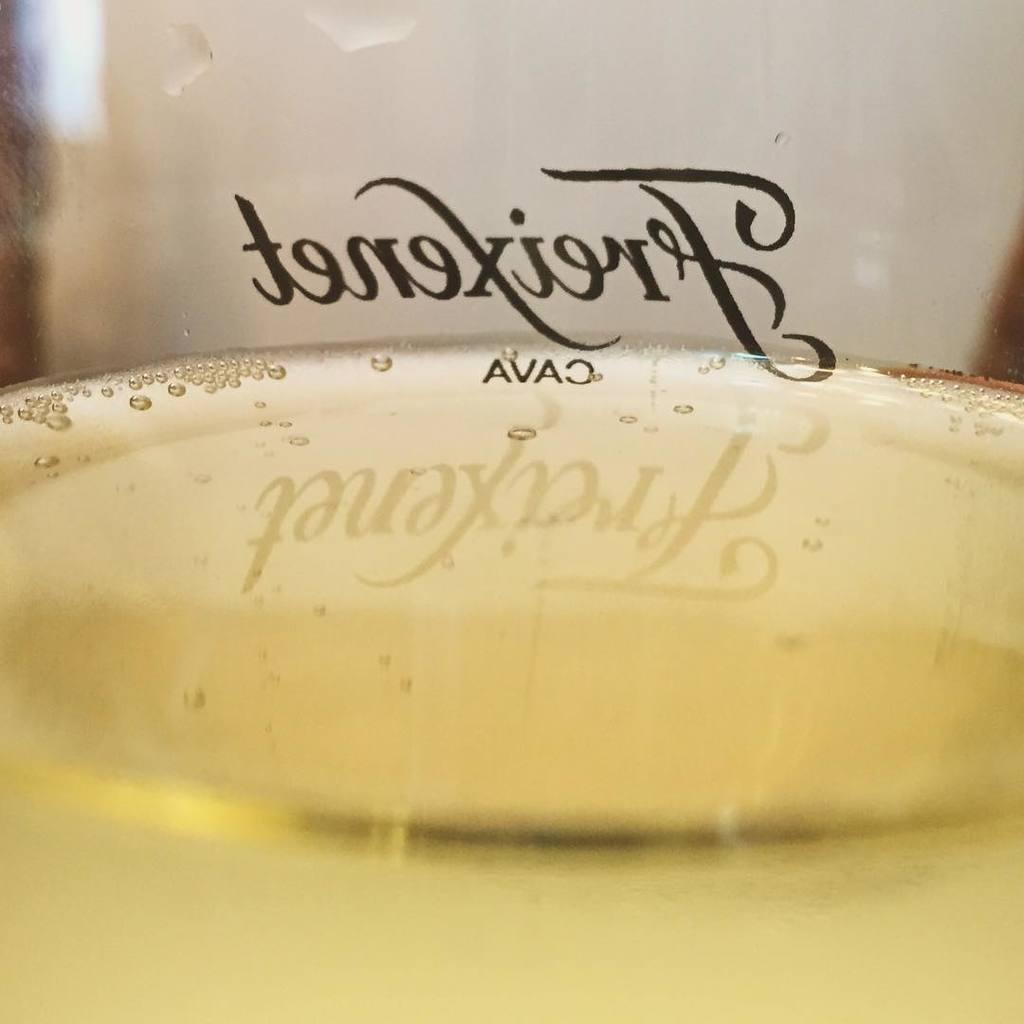Could you give a brief overview of what you see in this image? In the center of the image we can see water in the glass. And we can see some text on the glass. In the background we can see a few other objects. 